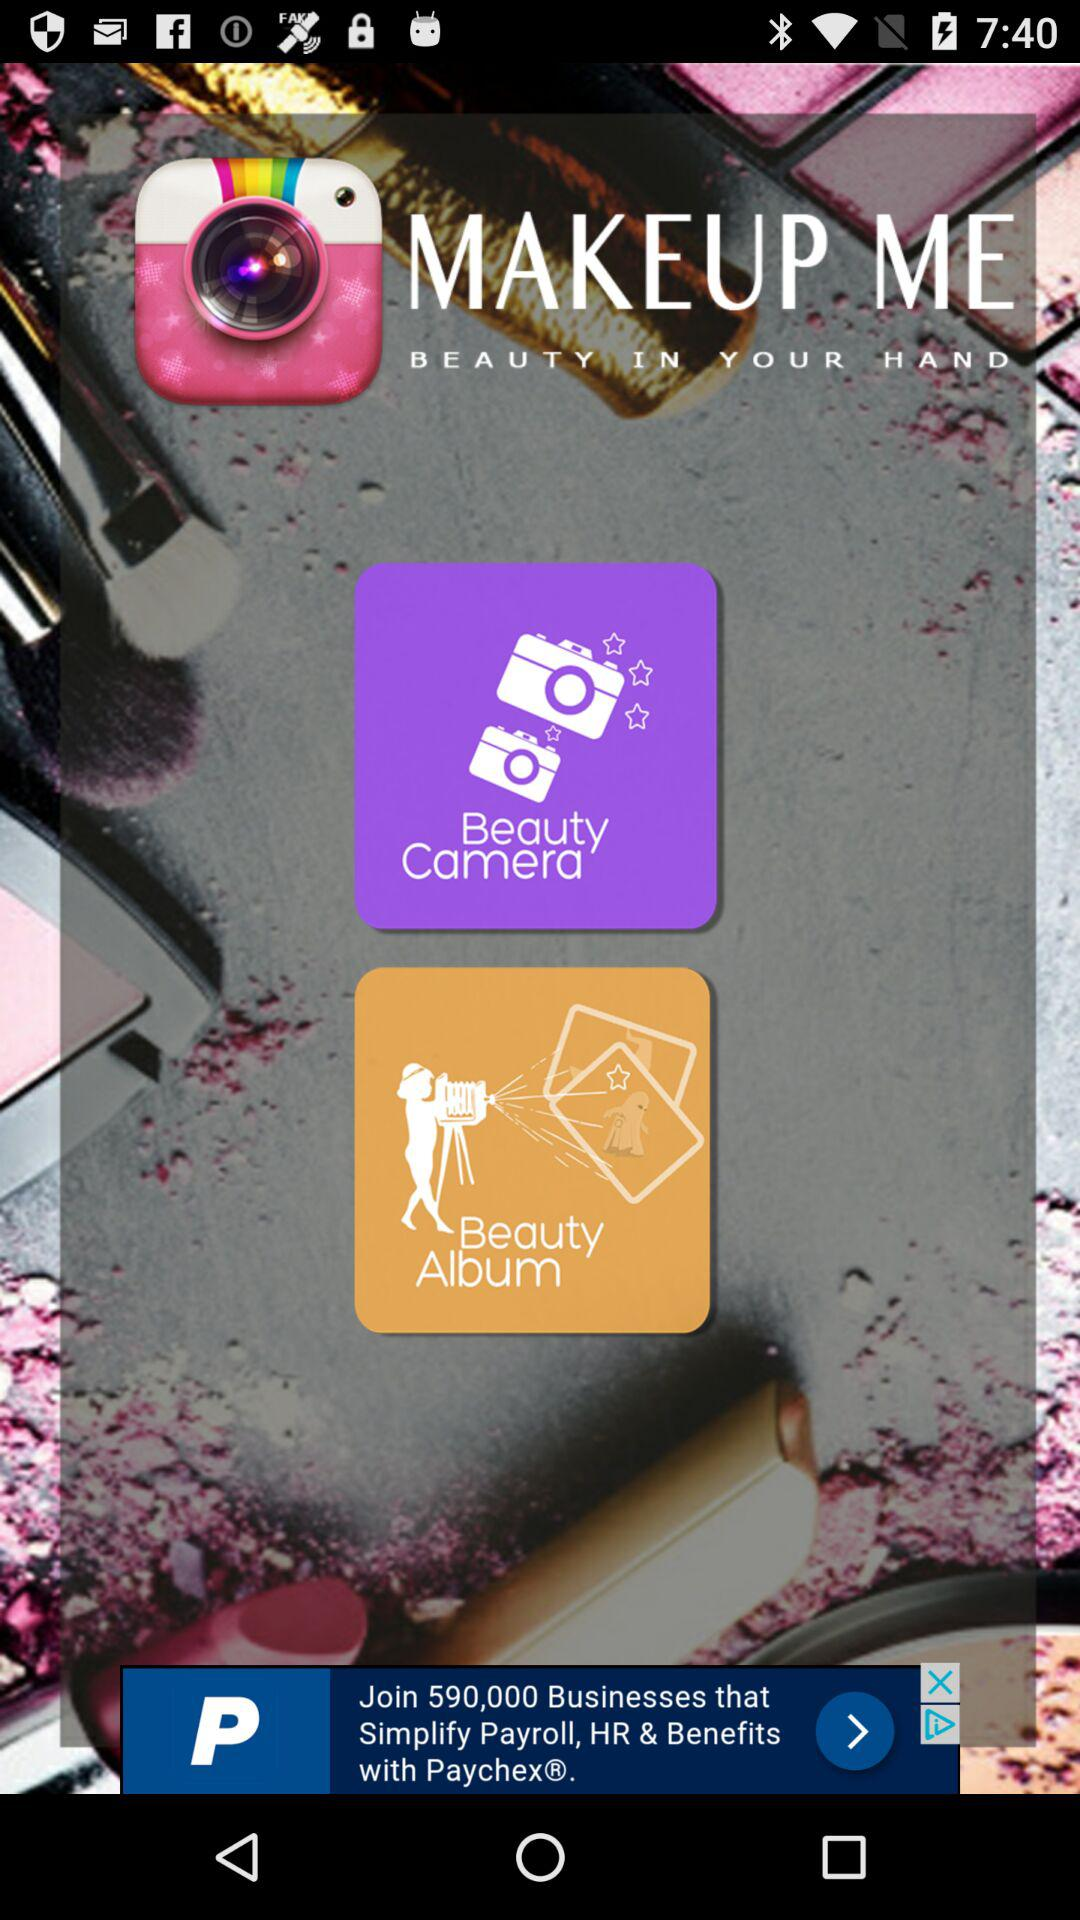What is the name of the application? The name of the application is "MAKEUP ME". 